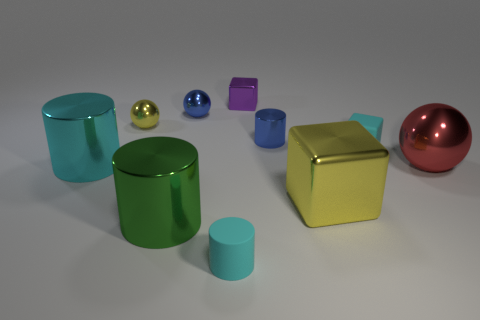Subtract all blocks. How many objects are left? 7 Subtract all tiny rubber cubes. Subtract all rubber cubes. How many objects are left? 8 Add 4 tiny blue shiny objects. How many tiny blue shiny objects are left? 6 Add 4 tiny purple shiny objects. How many tiny purple shiny objects exist? 5 Subtract 0 yellow cylinders. How many objects are left? 10 